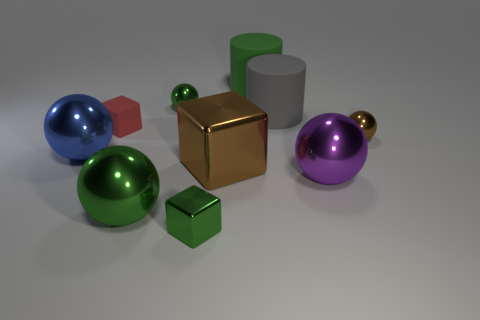Subtract 1 balls. How many balls are left? 4 Subtract all large purple shiny balls. How many balls are left? 4 Subtract all brown spheres. How many spheres are left? 4 Subtract all brown balls. Subtract all brown cylinders. How many balls are left? 4 Subtract all blocks. How many objects are left? 7 Add 7 large gray things. How many large gray things are left? 8 Add 8 large purple balls. How many large purple balls exist? 9 Subtract 0 purple cylinders. How many objects are left? 10 Subtract all cyan cylinders. Subtract all large cylinders. How many objects are left? 8 